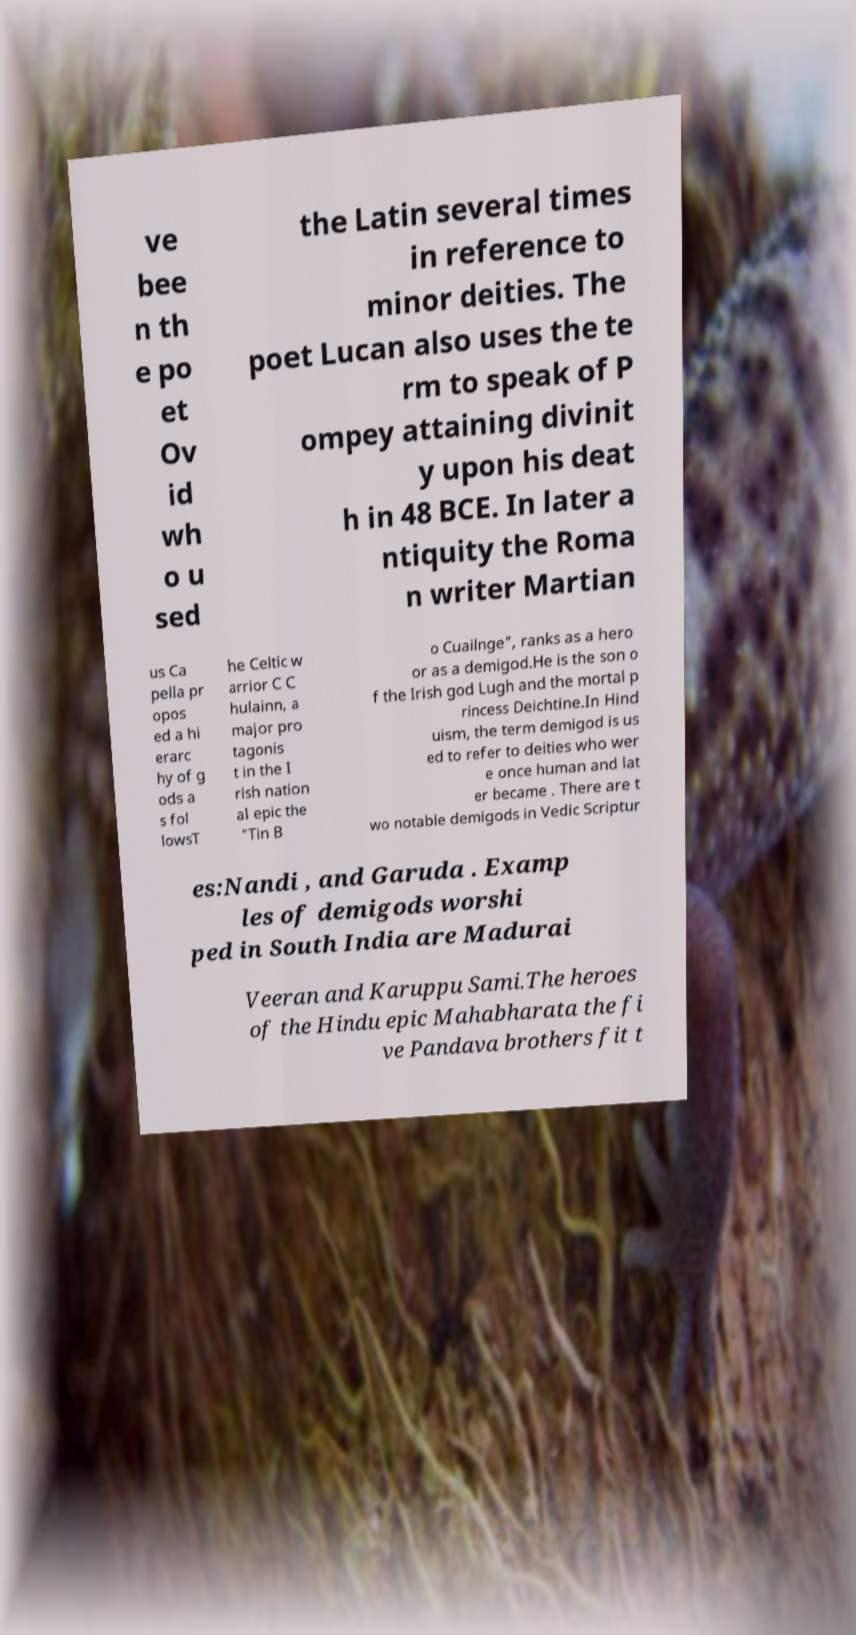Could you extract and type out the text from this image? ve bee n th e po et Ov id wh o u sed the Latin several times in reference to minor deities. The poet Lucan also uses the te rm to speak of P ompey attaining divinit y upon his deat h in 48 BCE. In later a ntiquity the Roma n writer Martian us Ca pella pr opos ed a hi erarc hy of g ods a s fol lowsT he Celtic w arrior C C hulainn, a major pro tagonis t in the I rish nation al epic the "Tin B o Cuailnge", ranks as a hero or as a demigod.He is the son o f the Irish god Lugh and the mortal p rincess Deichtine.In Hind uism, the term demigod is us ed to refer to deities who wer e once human and lat er became . There are t wo notable demigods in Vedic Scriptur es:Nandi , and Garuda . Examp les of demigods worshi ped in South India are Madurai Veeran and Karuppu Sami.The heroes of the Hindu epic Mahabharata the fi ve Pandava brothers fit t 